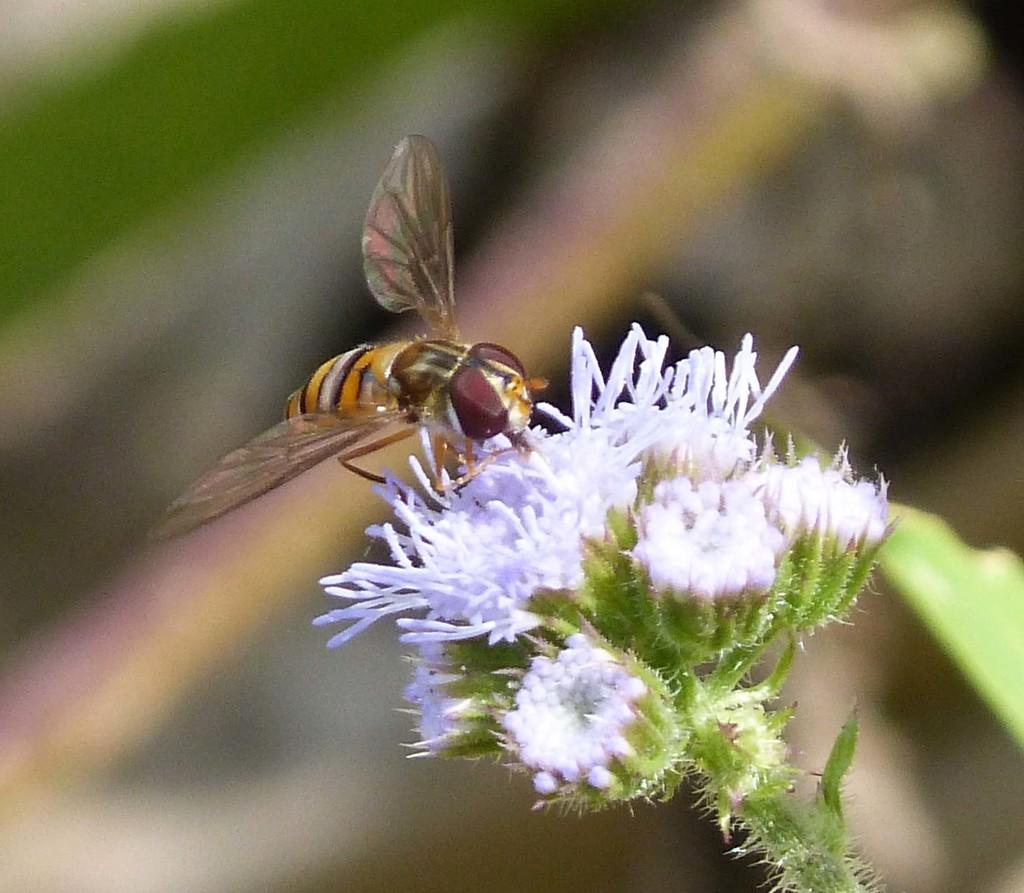What is the main subject of the image? There is a flower in the image. Can you describe the flower in more detail? The flower is on a stem. Are there any other living organisms present in the image? Yes, there is a bee on the flower. How would you describe the background of the image? The background of the image is blurred. What type of chess piece is located on the flower in the image? There is no chess piece present in the image; it features a flower with a bee on it. How many minutes does it take for the quiver to appear in the image? There is no quiver present in the image, so it cannot be determined how long it would take for it to appear. 